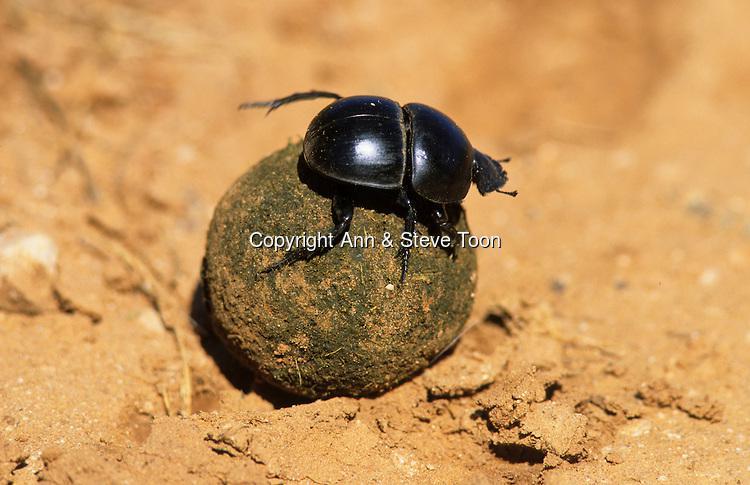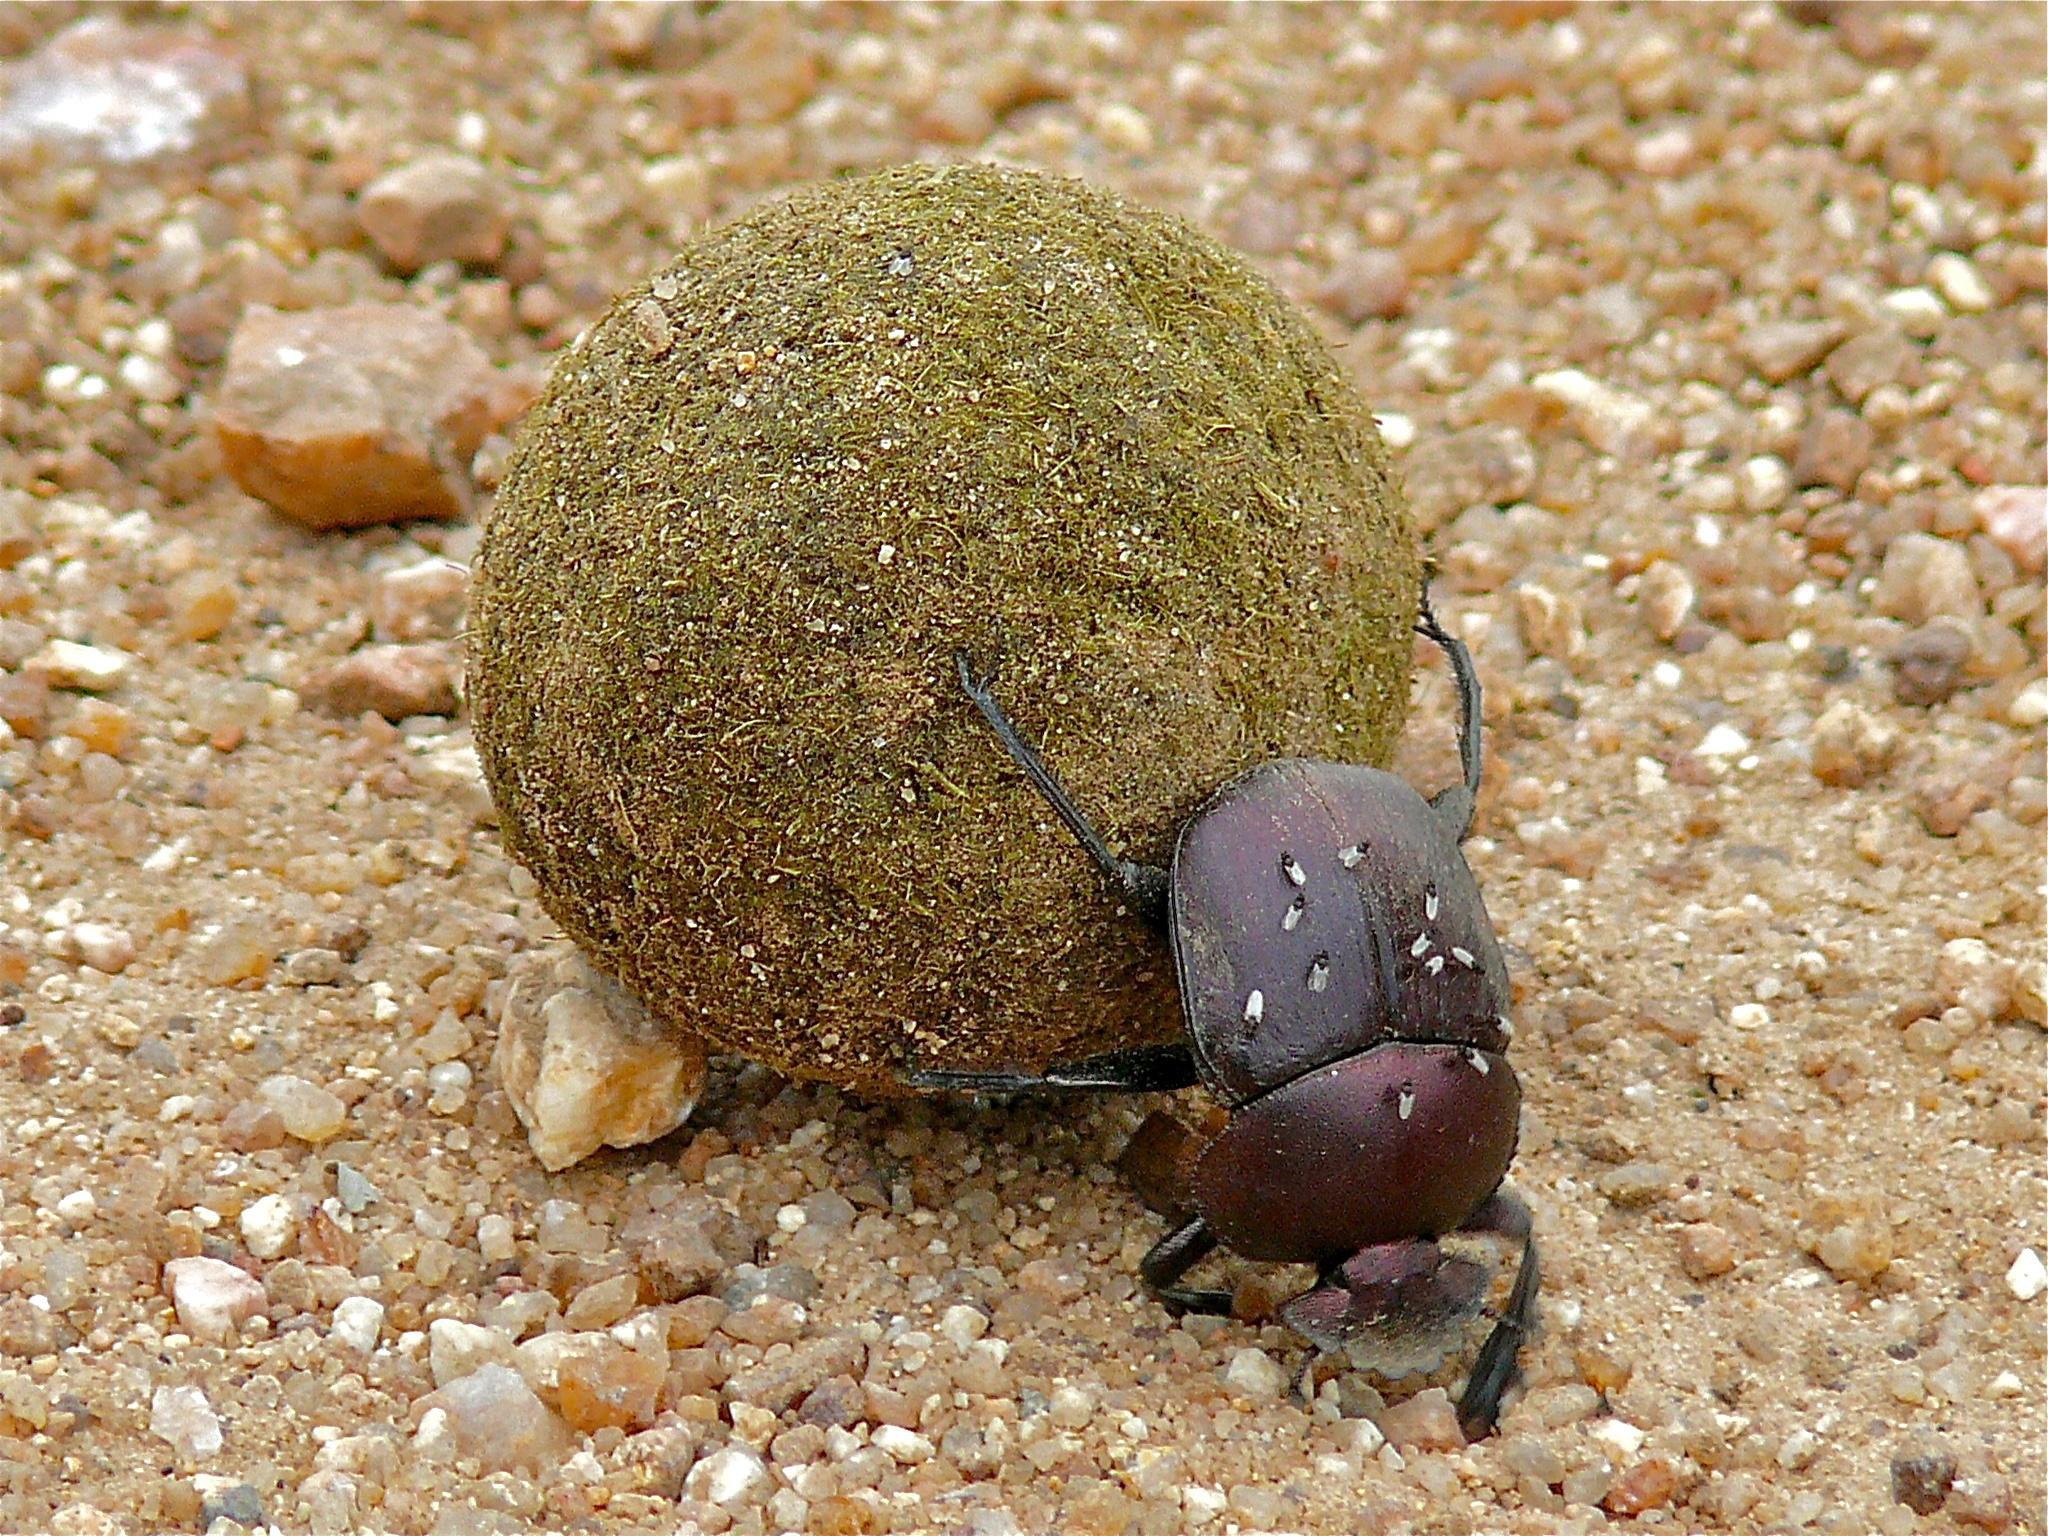The first image is the image on the left, the second image is the image on the right. Analyze the images presented: Is the assertion "Each image shows a beetle with a dungball that is bigger than the beetle." valid? Answer yes or no. Yes. The first image is the image on the left, the second image is the image on the right. Assess this claim about the two images: "There is a beetle on top of a dung ball.". Correct or not? Answer yes or no. Yes. 